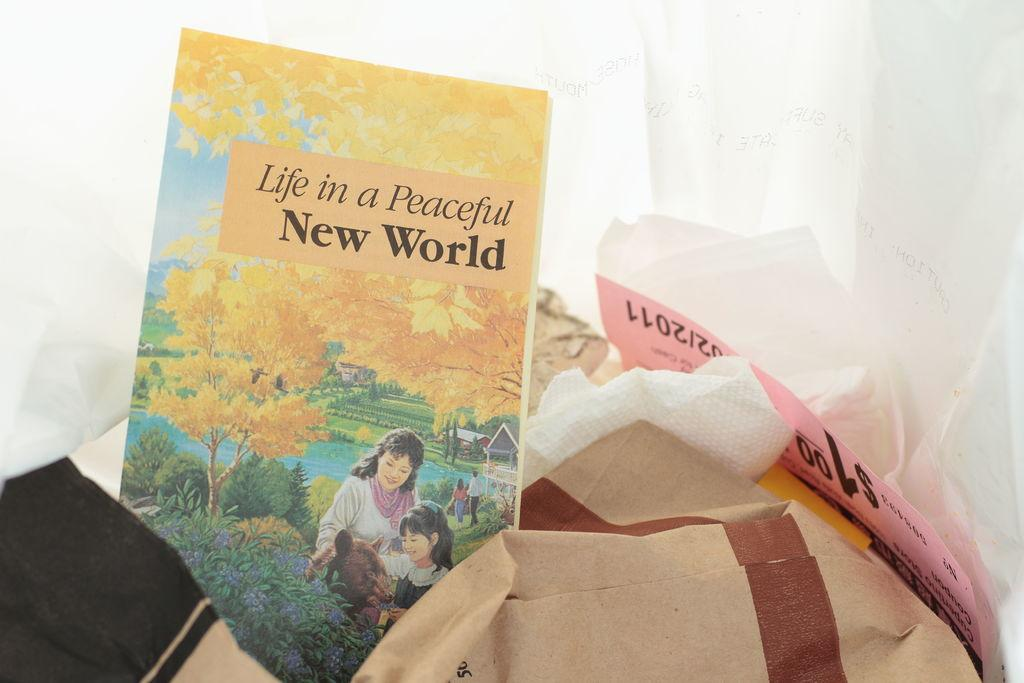<image>
Offer a succinct explanation of the picture presented. A small pamphlet is titled Life in a Peaceful New World. 